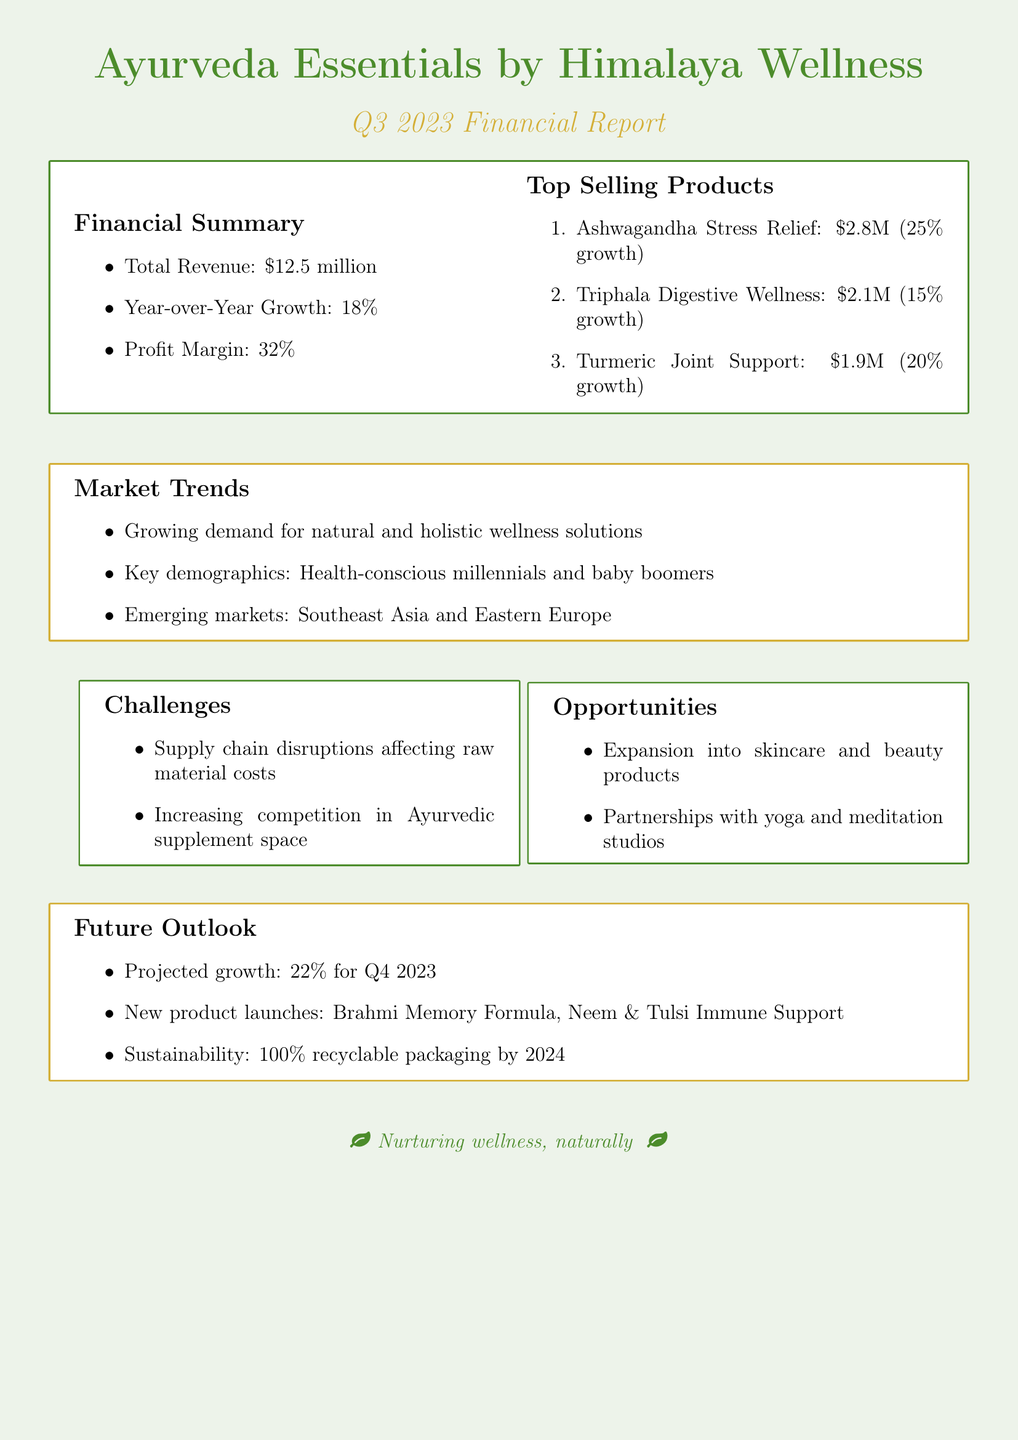What is the total revenue for Q3 2023? The total revenue reported for Q3 2023 is $12.5 million.
Answer: $12.5 million What is the year-over-year growth percentage? The document states that the year-over-year growth is 18%.
Answer: 18% What is the profit margin for the Ayurvedic product line? According to the financial summary, the profit margin is 32%.
Answer: 32% Which product generated the highest revenue? The product with the highest revenue is Ashwagandha Stress Relief Supplement, with $2.8 million.
Answer: Ashwagandha Stress Relief Supplement What is the projected growth for Q4 2023? The document projects a growth of 22% for Q4 2023.
Answer: 22% Which demographic is highlighted as a key market? Health-conscious millennials and baby boomers are identified as key demographics in the market trends section.
Answer: Health-conscious millennials and baby boomers What new product launches are mentioned for the future? The new product launches mentioned are Brahmi Memory Enhancement Formula and Neem & Tulsi Immune Support Blend.
Answer: Brahmi Memory Enhancement Formula, Neem & Tulsi Immune Support Blend What challenge is listed regarding the supply chain? A challenge listed is supply chain disruptions affecting raw material costs.
Answer: Supply chain disruptions affecting raw material costs What sustainability initiative is planned by 2024? The document mentions a transition to 100% recyclable packaging by 2024 as a sustainability initiative.
Answer: 100% recyclable packaging by 2024 